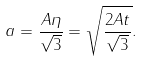<formula> <loc_0><loc_0><loc_500><loc_500>a = \frac { A \eta } { \sqrt { 3 } } = \sqrt { \frac { 2 A t } { \sqrt { 3 } } } .</formula> 